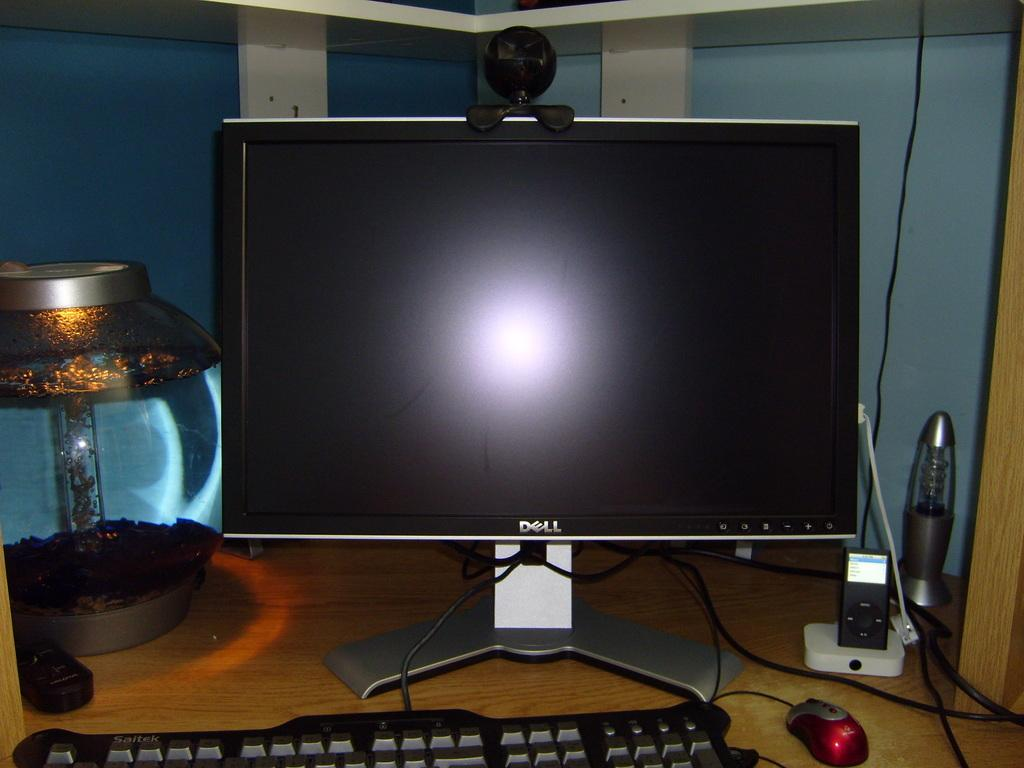<image>
Render a clear and concise summary of the photo. A dell computer monitor and keyboard are set up on a desk next to an ipod and a fish bowl. 